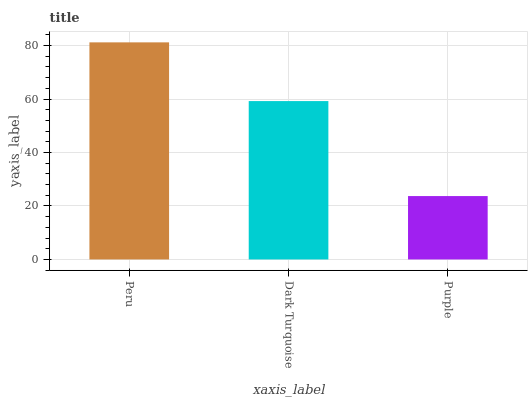Is Purple the minimum?
Answer yes or no. Yes. Is Peru the maximum?
Answer yes or no. Yes. Is Dark Turquoise the minimum?
Answer yes or no. No. Is Dark Turquoise the maximum?
Answer yes or no. No. Is Peru greater than Dark Turquoise?
Answer yes or no. Yes. Is Dark Turquoise less than Peru?
Answer yes or no. Yes. Is Dark Turquoise greater than Peru?
Answer yes or no. No. Is Peru less than Dark Turquoise?
Answer yes or no. No. Is Dark Turquoise the high median?
Answer yes or no. Yes. Is Dark Turquoise the low median?
Answer yes or no. Yes. Is Purple the high median?
Answer yes or no. No. Is Purple the low median?
Answer yes or no. No. 